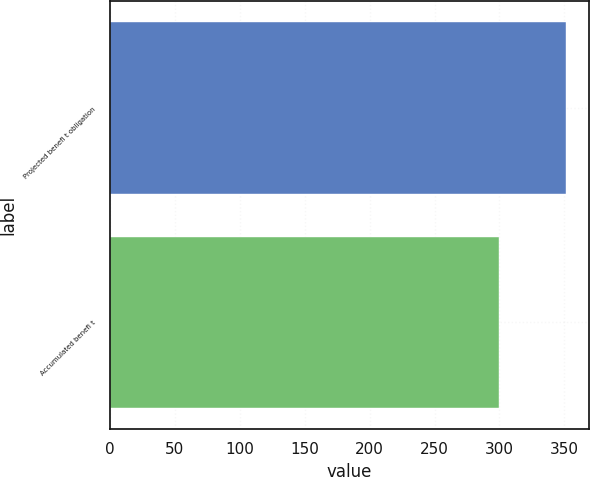<chart> <loc_0><loc_0><loc_500><loc_500><bar_chart><fcel>Projected benefi t obligation<fcel>Accumulated benefi t<nl><fcel>351.2<fcel>299.4<nl></chart> 